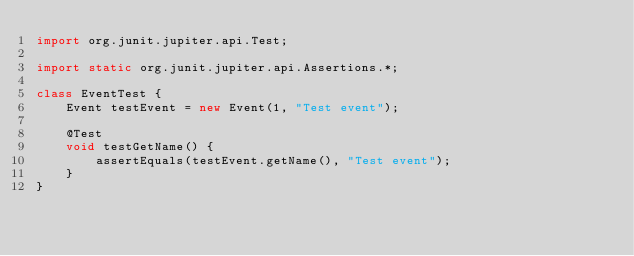<code> <loc_0><loc_0><loc_500><loc_500><_Java_>import org.junit.jupiter.api.Test;

import static org.junit.jupiter.api.Assertions.*;

class EventTest {
    Event testEvent = new Event(1, "Test event");

    @Test
    void testGetName() {
        assertEquals(testEvent.getName(), "Test event");
    }
}</code> 